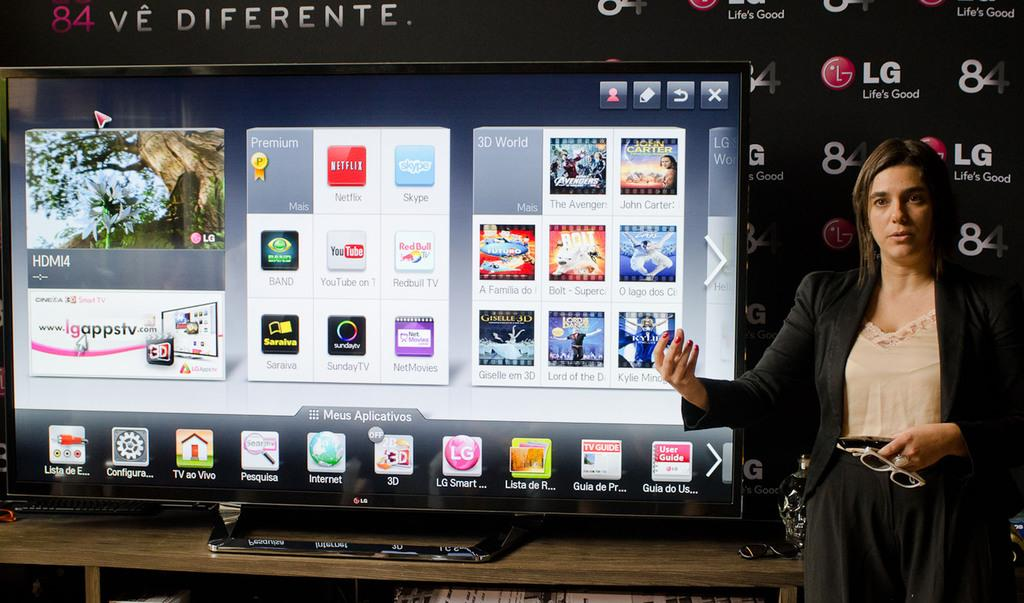<image>
Create a compact narrative representing the image presented. A woman stands next to a large LG television. 